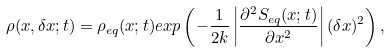<formula> <loc_0><loc_0><loc_500><loc_500>\rho ( x , \delta x ; t ) = \rho _ { e q } ( x ; t ) e x p \left ( - \frac { 1 } { 2 k } \left | \frac { \partial ^ { 2 } S _ { e q } ( x ; t ) } { \partial x ^ { 2 } } \right | ( \delta x ) ^ { 2 } \right ) ,</formula> 